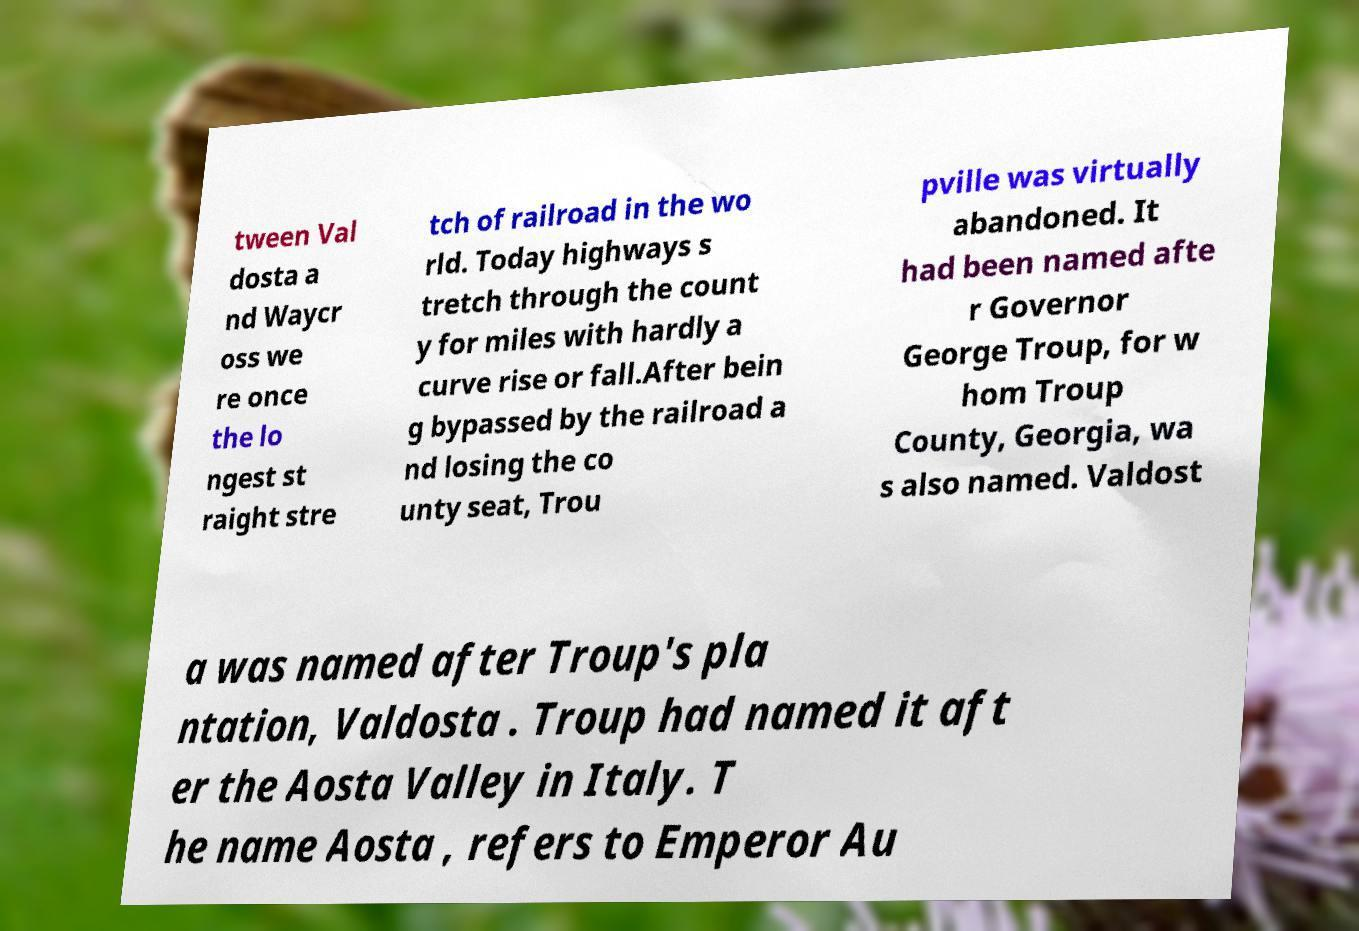Could you assist in decoding the text presented in this image and type it out clearly? tween Val dosta a nd Waycr oss we re once the lo ngest st raight stre tch of railroad in the wo rld. Today highways s tretch through the count y for miles with hardly a curve rise or fall.After bein g bypassed by the railroad a nd losing the co unty seat, Trou pville was virtually abandoned. It had been named afte r Governor George Troup, for w hom Troup County, Georgia, wa s also named. Valdost a was named after Troup's pla ntation, Valdosta . Troup had named it aft er the Aosta Valley in Italy. T he name Aosta , refers to Emperor Au 